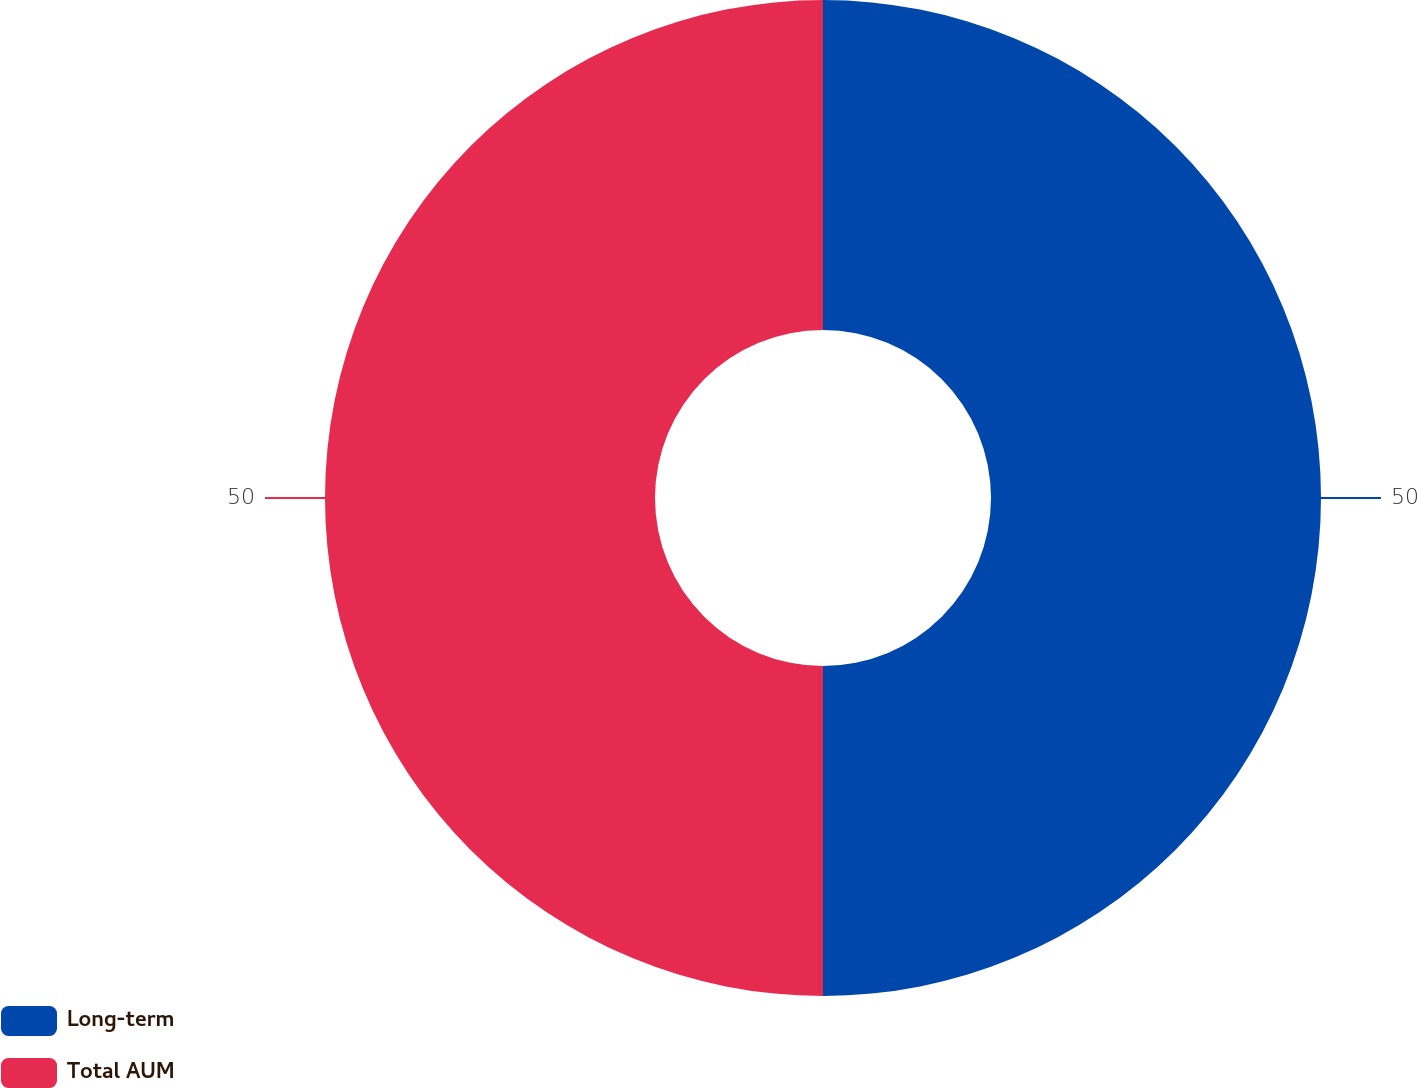Convert chart to OTSL. <chart><loc_0><loc_0><loc_500><loc_500><pie_chart><fcel>Long-term<fcel>Total AUM<nl><fcel>50.0%<fcel>50.0%<nl></chart> 